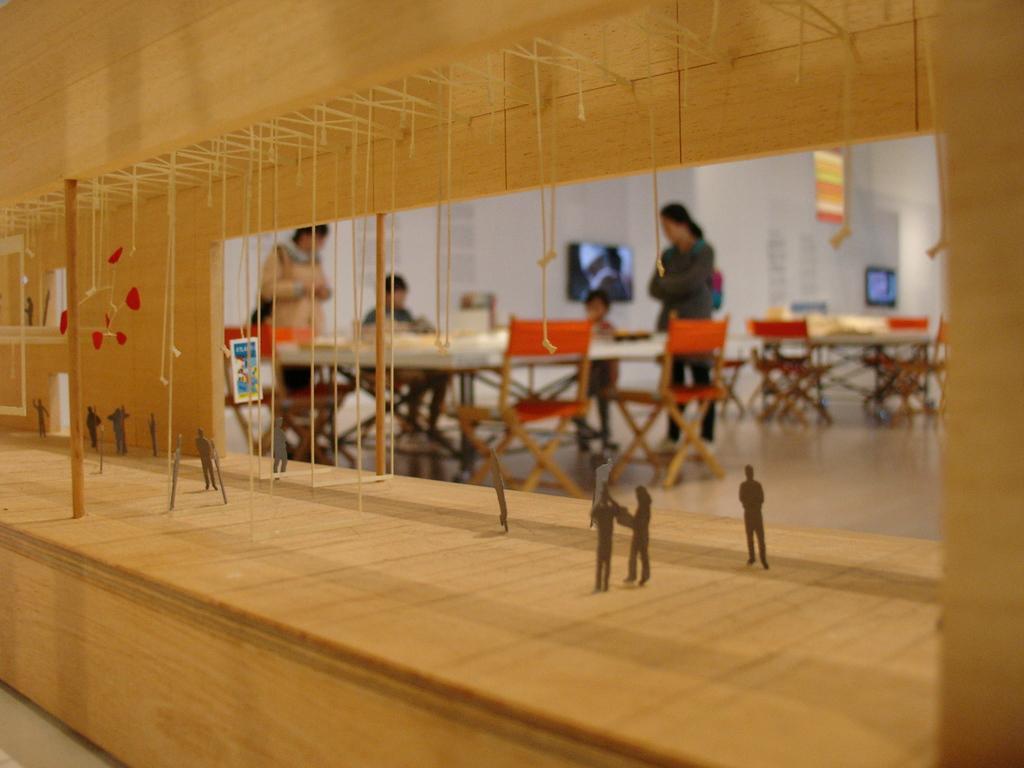Please provide a concise description of this image. In this image in the foreground there is a wooden fence visible , on which there might be some ropes and some other objects visible, through fence I can see tables, chairs, persons visible on the foreground , there is a wall, on the wall there are some screens attached in the middle. 